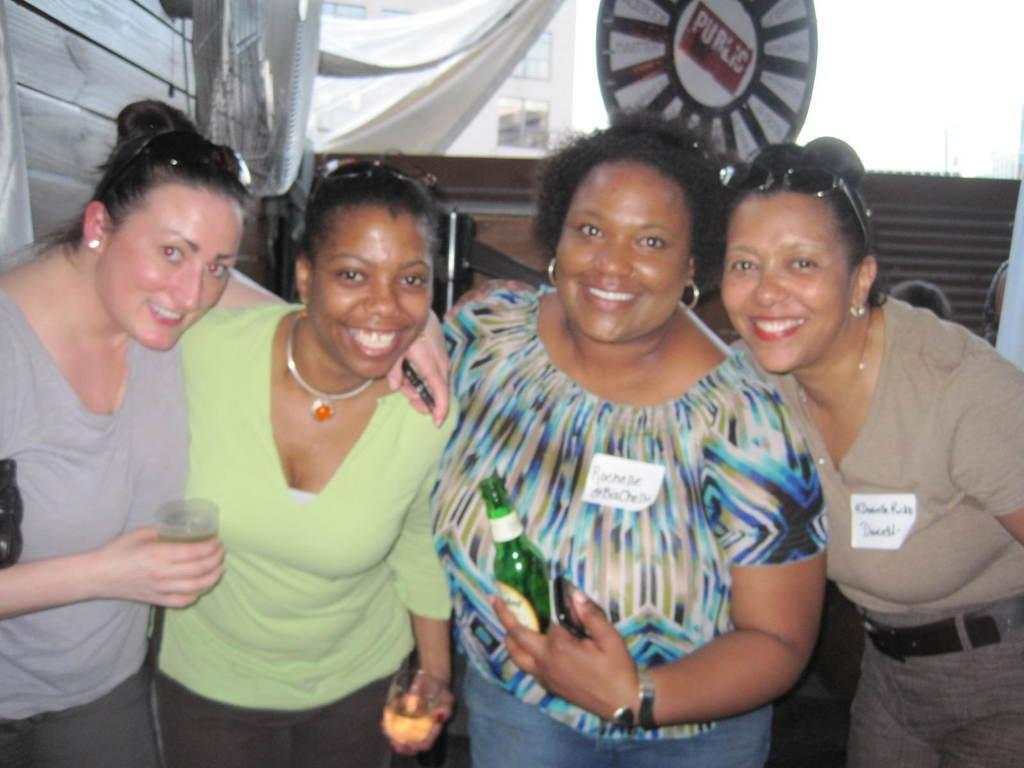Describe this image in one or two sentences. In this image I see 4 women who are smiling and I see that these both women are holding glasses in their hands and this woman is holding a bottle in her hand and I can also see that this woman is holding another in her hand. In the background I see the white color thing over here and I see something is written over here. 